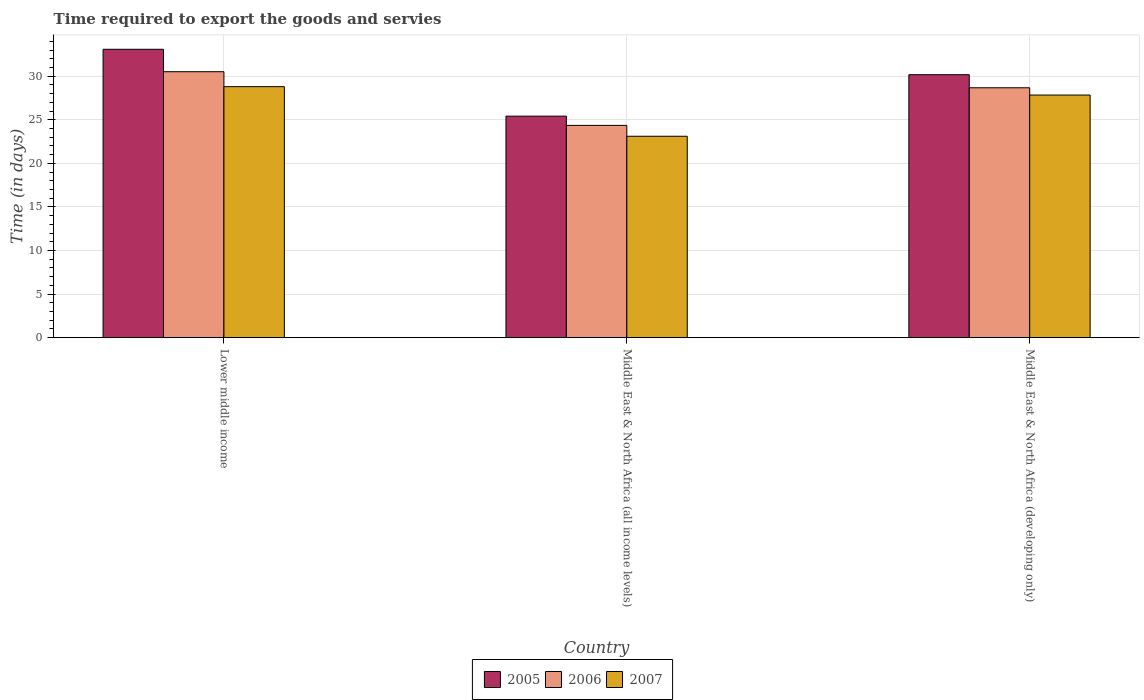How many groups of bars are there?
Your answer should be compact. 3. Are the number of bars per tick equal to the number of legend labels?
Keep it short and to the point. Yes. What is the label of the 2nd group of bars from the left?
Provide a succinct answer. Middle East & North Africa (all income levels). In how many cases, is the number of bars for a given country not equal to the number of legend labels?
Make the answer very short. 0. What is the number of days required to export the goods and services in 2007 in Middle East & North Africa (all income levels)?
Provide a succinct answer. 23.11. Across all countries, what is the maximum number of days required to export the goods and services in 2005?
Give a very brief answer. 33.08. Across all countries, what is the minimum number of days required to export the goods and services in 2007?
Offer a terse response. 23.11. In which country was the number of days required to export the goods and services in 2006 maximum?
Make the answer very short. Lower middle income. In which country was the number of days required to export the goods and services in 2005 minimum?
Offer a very short reply. Middle East & North Africa (all income levels). What is the total number of days required to export the goods and services in 2005 in the graph?
Provide a succinct answer. 88.66. What is the difference between the number of days required to export the goods and services in 2007 in Middle East & North Africa (all income levels) and that in Middle East & North Africa (developing only)?
Offer a terse response. -4.73. What is the difference between the number of days required to export the goods and services in 2006 in Middle East & North Africa (all income levels) and the number of days required to export the goods and services in 2005 in Middle East & North Africa (developing only)?
Your answer should be compact. -5.81. What is the average number of days required to export the goods and services in 2005 per country?
Provide a succinct answer. 29.55. What is the difference between the number of days required to export the goods and services of/in 2006 and number of days required to export the goods and services of/in 2005 in Middle East & North Africa (developing only)?
Offer a very short reply. -1.5. What is the ratio of the number of days required to export the goods and services in 2006 in Lower middle income to that in Middle East & North Africa (all income levels)?
Make the answer very short. 1.25. What is the difference between the highest and the second highest number of days required to export the goods and services in 2005?
Offer a very short reply. 2.91. What is the difference between the highest and the lowest number of days required to export the goods and services in 2007?
Provide a short and direct response. 5.69. What does the 1st bar from the left in Middle East & North Africa (all income levels) represents?
Your answer should be compact. 2005. How many bars are there?
Offer a terse response. 9. Are all the bars in the graph horizontal?
Your answer should be compact. No. What is the difference between two consecutive major ticks on the Y-axis?
Offer a terse response. 5. Are the values on the major ticks of Y-axis written in scientific E-notation?
Give a very brief answer. No. Where does the legend appear in the graph?
Your response must be concise. Bottom center. What is the title of the graph?
Give a very brief answer. Time required to export the goods and servies. Does "1998" appear as one of the legend labels in the graph?
Provide a short and direct response. No. What is the label or title of the Y-axis?
Keep it short and to the point. Time (in days). What is the Time (in days) in 2005 in Lower middle income?
Keep it short and to the point. 33.08. What is the Time (in days) of 2006 in Lower middle income?
Offer a very short reply. 30.51. What is the Time (in days) of 2007 in Lower middle income?
Offer a terse response. 28.8. What is the Time (in days) of 2005 in Middle East & North Africa (all income levels)?
Keep it short and to the point. 25.41. What is the Time (in days) in 2006 in Middle East & North Africa (all income levels)?
Offer a terse response. 24.35. What is the Time (in days) of 2007 in Middle East & North Africa (all income levels)?
Your answer should be very brief. 23.11. What is the Time (in days) in 2005 in Middle East & North Africa (developing only)?
Provide a succinct answer. 30.17. What is the Time (in days) in 2006 in Middle East & North Africa (developing only)?
Make the answer very short. 28.67. What is the Time (in days) of 2007 in Middle East & North Africa (developing only)?
Your response must be concise. 27.83. Across all countries, what is the maximum Time (in days) of 2005?
Offer a terse response. 33.08. Across all countries, what is the maximum Time (in days) in 2006?
Offer a very short reply. 30.51. Across all countries, what is the maximum Time (in days) in 2007?
Ensure brevity in your answer.  28.8. Across all countries, what is the minimum Time (in days) in 2005?
Make the answer very short. 25.41. Across all countries, what is the minimum Time (in days) in 2006?
Provide a succinct answer. 24.35. Across all countries, what is the minimum Time (in days) of 2007?
Provide a short and direct response. 23.11. What is the total Time (in days) in 2005 in the graph?
Ensure brevity in your answer.  88.66. What is the total Time (in days) in 2006 in the graph?
Your answer should be compact. 83.53. What is the total Time (in days) in 2007 in the graph?
Make the answer very short. 79.73. What is the difference between the Time (in days) of 2005 in Lower middle income and that in Middle East & North Africa (all income levels)?
Your response must be concise. 7.67. What is the difference between the Time (in days) in 2006 in Lower middle income and that in Middle East & North Africa (all income levels)?
Your response must be concise. 6.16. What is the difference between the Time (in days) in 2007 in Lower middle income and that in Middle East & North Africa (all income levels)?
Give a very brief answer. 5.69. What is the difference between the Time (in days) of 2005 in Lower middle income and that in Middle East & North Africa (developing only)?
Give a very brief answer. 2.92. What is the difference between the Time (in days) in 2006 in Lower middle income and that in Middle East & North Africa (developing only)?
Provide a succinct answer. 1.84. What is the difference between the Time (in days) in 2007 in Lower middle income and that in Middle East & North Africa (developing only)?
Provide a short and direct response. 0.96. What is the difference between the Time (in days) of 2005 in Middle East & North Africa (all income levels) and that in Middle East & North Africa (developing only)?
Provide a short and direct response. -4.75. What is the difference between the Time (in days) of 2006 in Middle East & North Africa (all income levels) and that in Middle East & North Africa (developing only)?
Your response must be concise. -4.31. What is the difference between the Time (in days) in 2007 in Middle East & North Africa (all income levels) and that in Middle East & North Africa (developing only)?
Provide a succinct answer. -4.73. What is the difference between the Time (in days) of 2005 in Lower middle income and the Time (in days) of 2006 in Middle East & North Africa (all income levels)?
Make the answer very short. 8.73. What is the difference between the Time (in days) of 2005 in Lower middle income and the Time (in days) of 2007 in Middle East & North Africa (all income levels)?
Keep it short and to the point. 9.98. What is the difference between the Time (in days) of 2006 in Lower middle income and the Time (in days) of 2007 in Middle East & North Africa (all income levels)?
Make the answer very short. 7.4. What is the difference between the Time (in days) of 2005 in Lower middle income and the Time (in days) of 2006 in Middle East & North Africa (developing only)?
Your answer should be compact. 4.42. What is the difference between the Time (in days) of 2005 in Lower middle income and the Time (in days) of 2007 in Middle East & North Africa (developing only)?
Offer a very short reply. 5.25. What is the difference between the Time (in days) of 2006 in Lower middle income and the Time (in days) of 2007 in Middle East & North Africa (developing only)?
Offer a terse response. 2.68. What is the difference between the Time (in days) of 2005 in Middle East & North Africa (all income levels) and the Time (in days) of 2006 in Middle East & North Africa (developing only)?
Offer a terse response. -3.25. What is the difference between the Time (in days) in 2005 in Middle East & North Africa (all income levels) and the Time (in days) in 2007 in Middle East & North Africa (developing only)?
Your response must be concise. -2.42. What is the difference between the Time (in days) in 2006 in Middle East & North Africa (all income levels) and the Time (in days) in 2007 in Middle East & North Africa (developing only)?
Keep it short and to the point. -3.48. What is the average Time (in days) in 2005 per country?
Offer a very short reply. 29.55. What is the average Time (in days) in 2006 per country?
Your answer should be compact. 27.84. What is the average Time (in days) of 2007 per country?
Your answer should be compact. 26.58. What is the difference between the Time (in days) of 2005 and Time (in days) of 2006 in Lower middle income?
Provide a short and direct response. 2.57. What is the difference between the Time (in days) in 2005 and Time (in days) in 2007 in Lower middle income?
Ensure brevity in your answer.  4.29. What is the difference between the Time (in days) of 2006 and Time (in days) of 2007 in Lower middle income?
Your answer should be compact. 1.71. What is the difference between the Time (in days) in 2005 and Time (in days) in 2006 in Middle East & North Africa (all income levels)?
Your response must be concise. 1.06. What is the difference between the Time (in days) in 2005 and Time (in days) in 2007 in Middle East & North Africa (all income levels)?
Give a very brief answer. 2.31. What is the difference between the Time (in days) in 2006 and Time (in days) in 2007 in Middle East & North Africa (all income levels)?
Make the answer very short. 1.25. What is the difference between the Time (in days) in 2005 and Time (in days) in 2006 in Middle East & North Africa (developing only)?
Your answer should be compact. 1.5. What is the difference between the Time (in days) in 2005 and Time (in days) in 2007 in Middle East & North Africa (developing only)?
Provide a short and direct response. 2.33. What is the difference between the Time (in days) in 2006 and Time (in days) in 2007 in Middle East & North Africa (developing only)?
Provide a short and direct response. 0.83. What is the ratio of the Time (in days) in 2005 in Lower middle income to that in Middle East & North Africa (all income levels)?
Offer a terse response. 1.3. What is the ratio of the Time (in days) in 2006 in Lower middle income to that in Middle East & North Africa (all income levels)?
Your answer should be compact. 1.25. What is the ratio of the Time (in days) of 2007 in Lower middle income to that in Middle East & North Africa (all income levels)?
Offer a very short reply. 1.25. What is the ratio of the Time (in days) in 2005 in Lower middle income to that in Middle East & North Africa (developing only)?
Keep it short and to the point. 1.1. What is the ratio of the Time (in days) of 2006 in Lower middle income to that in Middle East & North Africa (developing only)?
Ensure brevity in your answer.  1.06. What is the ratio of the Time (in days) of 2007 in Lower middle income to that in Middle East & North Africa (developing only)?
Your response must be concise. 1.03. What is the ratio of the Time (in days) of 2005 in Middle East & North Africa (all income levels) to that in Middle East & North Africa (developing only)?
Keep it short and to the point. 0.84. What is the ratio of the Time (in days) of 2006 in Middle East & North Africa (all income levels) to that in Middle East & North Africa (developing only)?
Your response must be concise. 0.85. What is the ratio of the Time (in days) in 2007 in Middle East & North Africa (all income levels) to that in Middle East & North Africa (developing only)?
Make the answer very short. 0.83. What is the difference between the highest and the second highest Time (in days) of 2005?
Provide a succinct answer. 2.92. What is the difference between the highest and the second highest Time (in days) in 2006?
Your response must be concise. 1.84. What is the difference between the highest and the second highest Time (in days) of 2007?
Ensure brevity in your answer.  0.96. What is the difference between the highest and the lowest Time (in days) in 2005?
Keep it short and to the point. 7.67. What is the difference between the highest and the lowest Time (in days) in 2006?
Keep it short and to the point. 6.16. What is the difference between the highest and the lowest Time (in days) of 2007?
Your response must be concise. 5.69. 